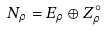<formula> <loc_0><loc_0><loc_500><loc_500>N _ { \rho } = E _ { \rho } \oplus Z _ { \rho } ^ { \circ }</formula> 